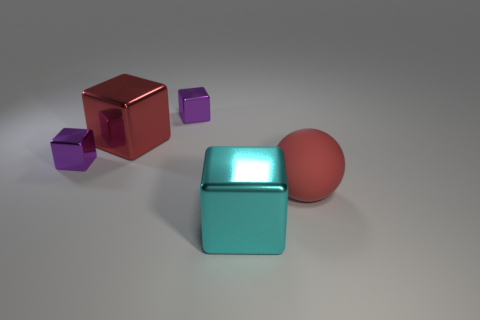How many purple blocks must be subtracted to get 1 purple blocks? 1 Add 3 red matte balls. How many objects exist? 8 Subtract all blocks. How many objects are left? 1 Subtract all cubes. Subtract all spheres. How many objects are left? 0 Add 5 big metal things. How many big metal things are left? 7 Add 1 purple blocks. How many purple blocks exist? 3 Subtract 0 brown cubes. How many objects are left? 5 